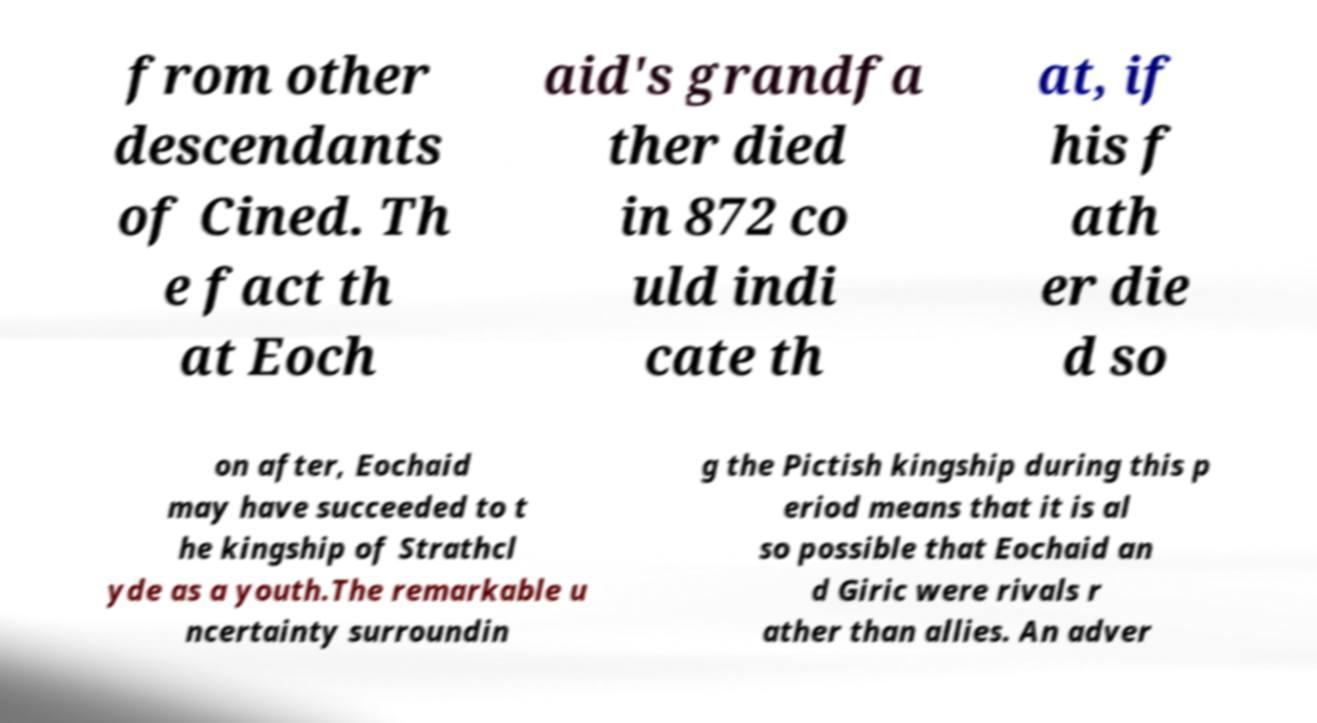I need the written content from this picture converted into text. Can you do that? from other descendants of Cined. Th e fact th at Eoch aid's grandfa ther died in 872 co uld indi cate th at, if his f ath er die d so on after, Eochaid may have succeeded to t he kingship of Strathcl yde as a youth.The remarkable u ncertainty surroundin g the Pictish kingship during this p eriod means that it is al so possible that Eochaid an d Giric were rivals r ather than allies. An adver 